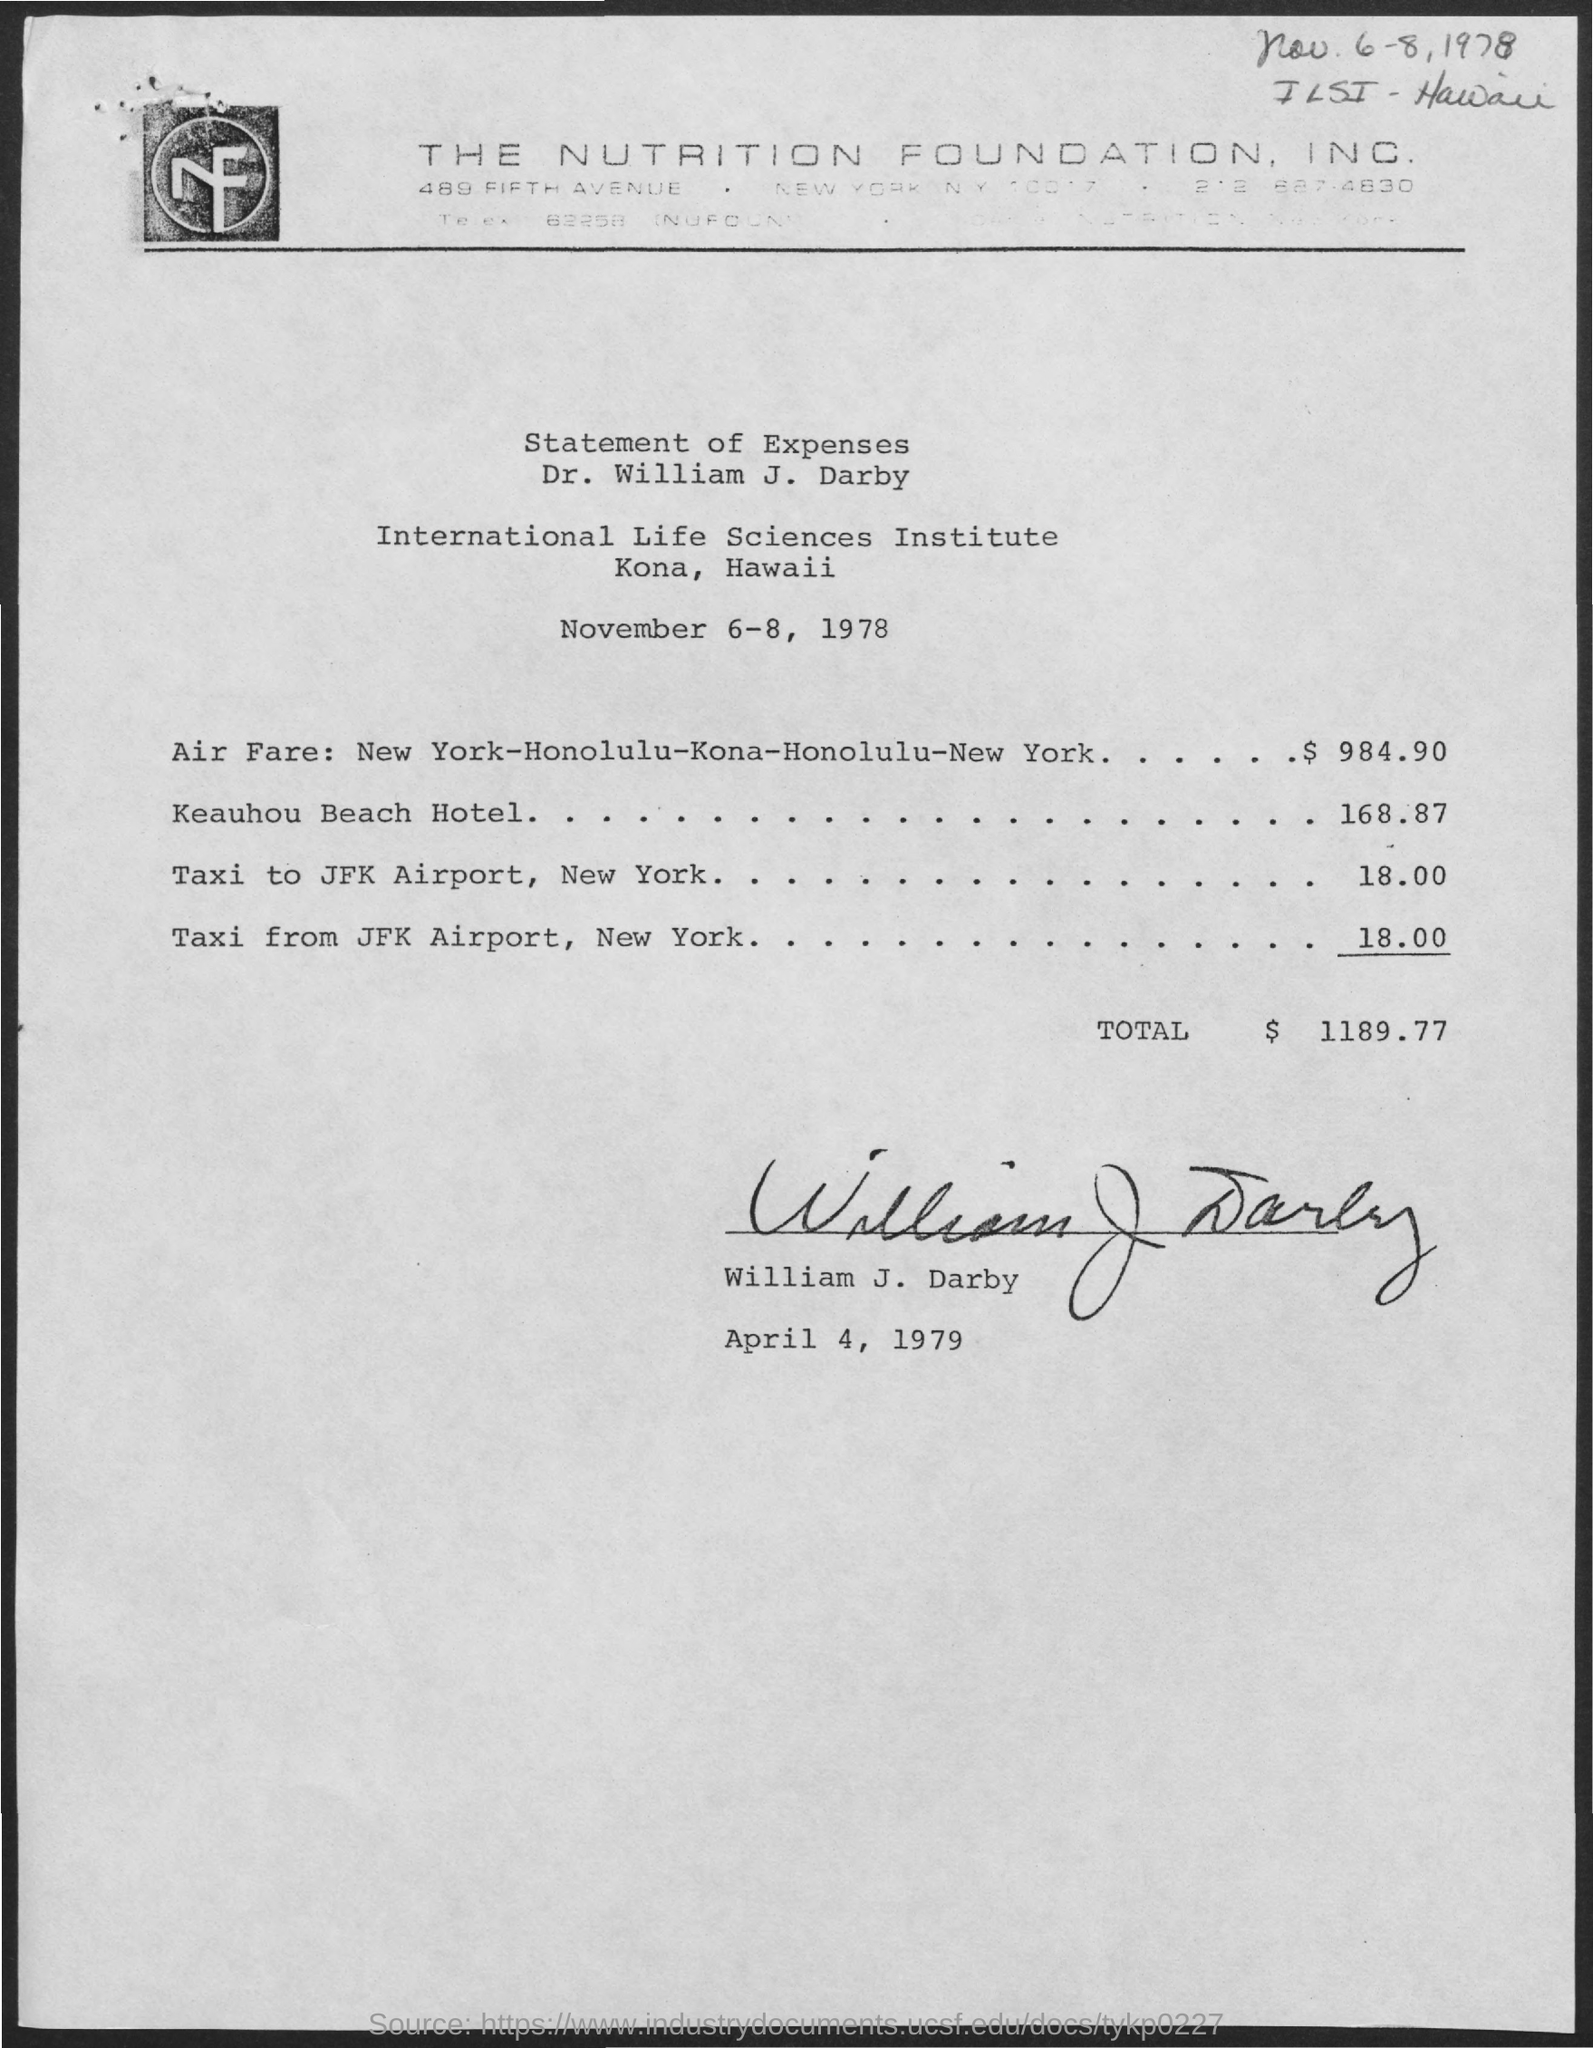To whom the statement of expenses belongs to ?
Your response must be concise. Dr. William J. Darby. What is the name of  the institute mentioned in the given page ?
Ensure brevity in your answer.  International Life Sciences  institute. What are the expenses for air fare :new york- honolulu-kona-honolulu-new york ?
Keep it short and to the point. 984.90. What are the expenses for keauhou beach hotel ?
Make the answer very short. 168.87. What are the expenses for taxi to jkf airport,new york ?
Offer a very short reply. $ 18.00. What are the expenses for taxi from jkf airport,new york ?
Your answer should be very brief. $ 18.00. What are the total expenses mentioned in the given page ?
Your response must be concise. $ 1189.77. 